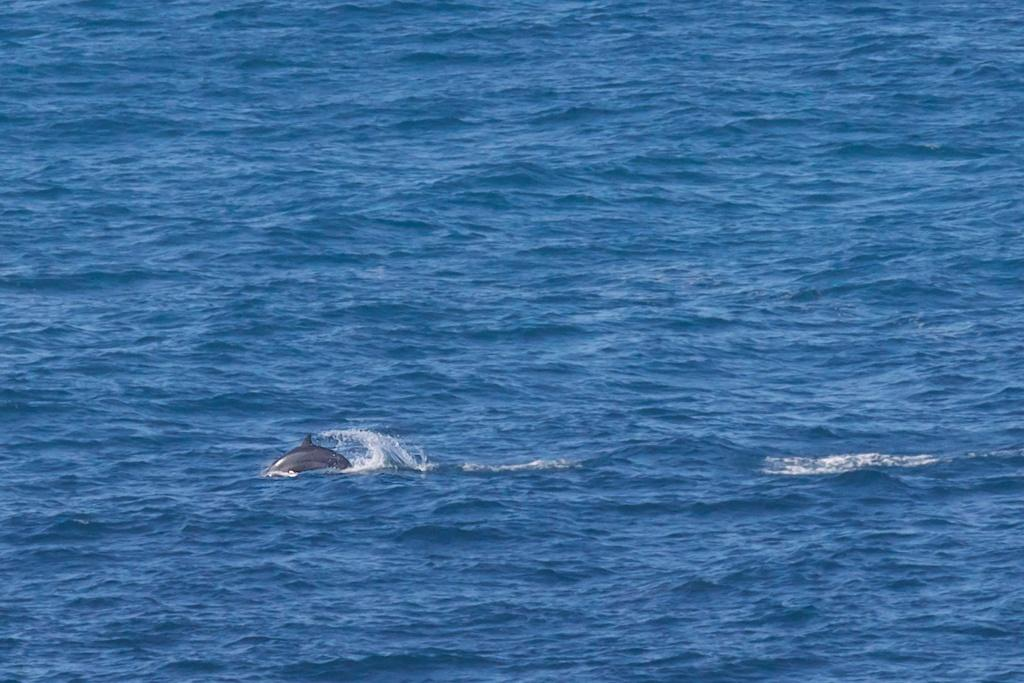What is present in the image? There is water visible in the image, and there is a dolphin in the image. Can you describe the dolphin in the image? The dolphin is swimming in the water. What type of unit is being used to measure the salt content in the image? There is no mention of salt or any unit of measurement in the image. Is there a rifle visible in the image? No, there is no rifle present in the image. 